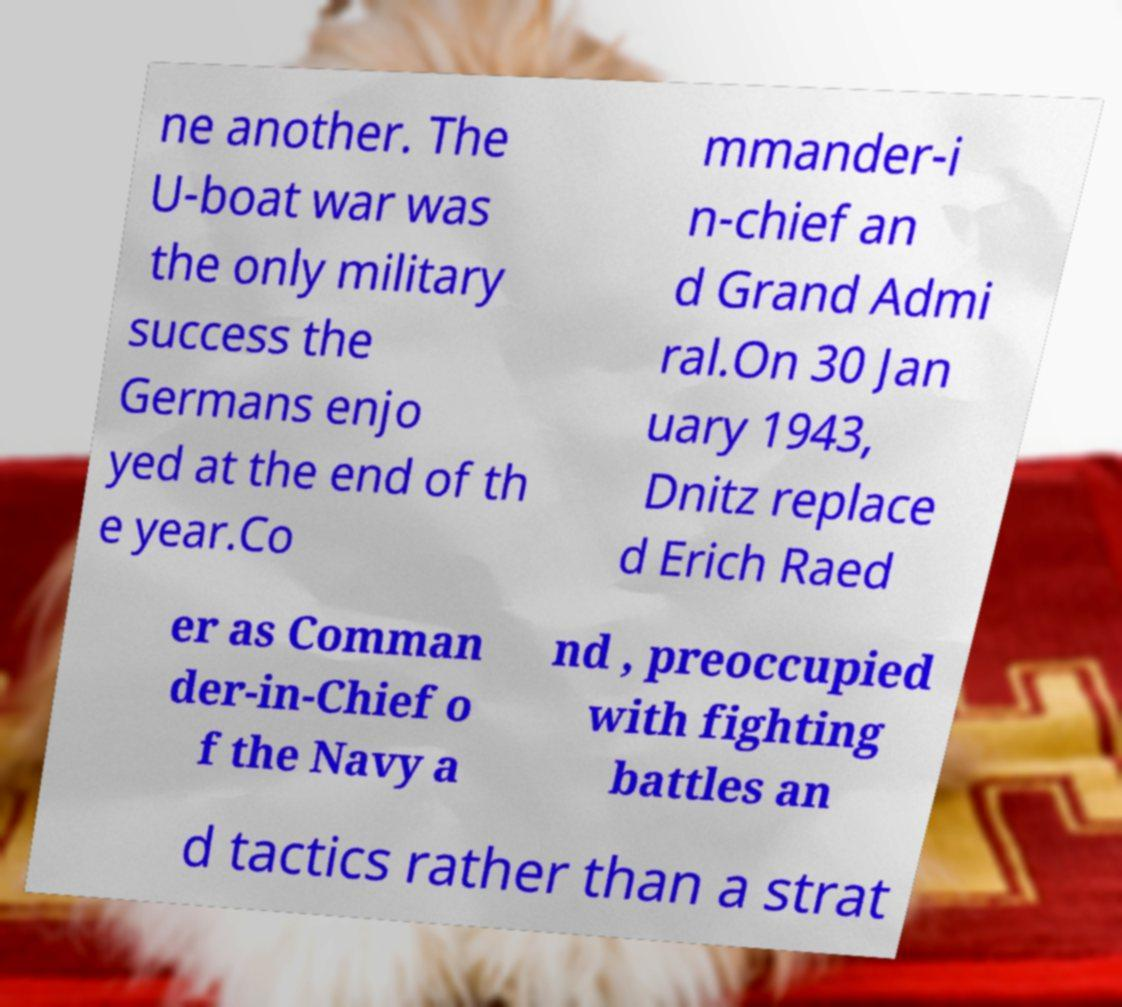What messages or text are displayed in this image? I need them in a readable, typed format. ne another. The U-boat war was the only military success the Germans enjo yed at the end of th e year.Co mmander-i n-chief an d Grand Admi ral.On 30 Jan uary 1943, Dnitz replace d Erich Raed er as Comman der-in-Chief o f the Navy a nd , preoccupied with fighting battles an d tactics rather than a strat 